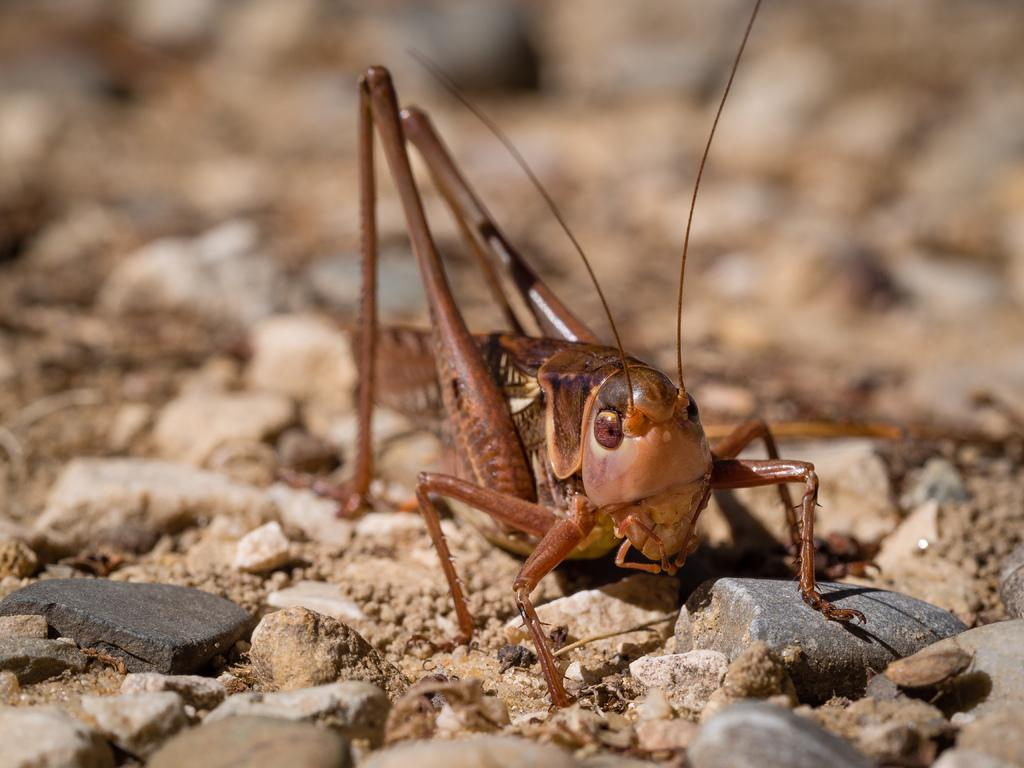What type of creature can be seen in the image? There is an insect in the image. Where is the insect located? The insect is on stones. How many accounts does the insect have in the image? There are no accounts present in the image, as it features an insect on stones. 